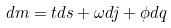<formula> <loc_0><loc_0><loc_500><loc_500>d m = t d s + \omega d j + \phi d q</formula> 